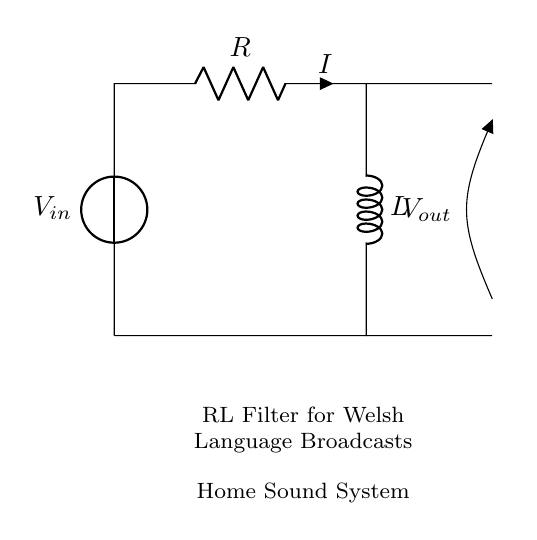What type of filter is represented in the circuit? The circuit shows an RL filter, which consists of a resistor (R) and an inductor (L) configured to filter frequencies in the Welsh language broadcasts.
Answer: RL filter What are the components in this circuit? The components include a resistor (R) and an inductor (L), which are essential for creating the filter effect. The voltage source (V in) and output voltage (V out) are also part of the circuit.
Answer: Resistor and Inductor What is the direction of the current indicated in the diagram? The diagram shows the direction of current (I) flowing through the resistor and inductor, which is typically from the voltage source to ground.
Answer: From top to bottom What happens to high-frequency signals in this circuit? In an RL filter, high-frequency signals are attenuated due to the inductor's inductive reactance increasing with frequency. This means they are reduced at the output (V out).
Answer: Attenuated What is the relationship between resistance and inductance in this filter? The resistance (R) influences the damping of the signal, while the inductance (L) determines the filter's frequency response. Together, they affect the circuit's performance in filtering.
Answer: Damping and filtering How can this RL filter be applied to Welsh language broadcasts? The RL filter can help reduce unwanted frequencies and noise in the sound system, allowing clearer reception of Welsh language broadcasts by targeting specific frequency ranges.
Answer: Clearer reception What is the output voltage measurement taken from across the inductor? The output voltage (V out) is measured across the inductor and indicates how much voltage falls across it after filtering, which is ideally representative of the audio signal intended for broadcasting.
Answer: V out 